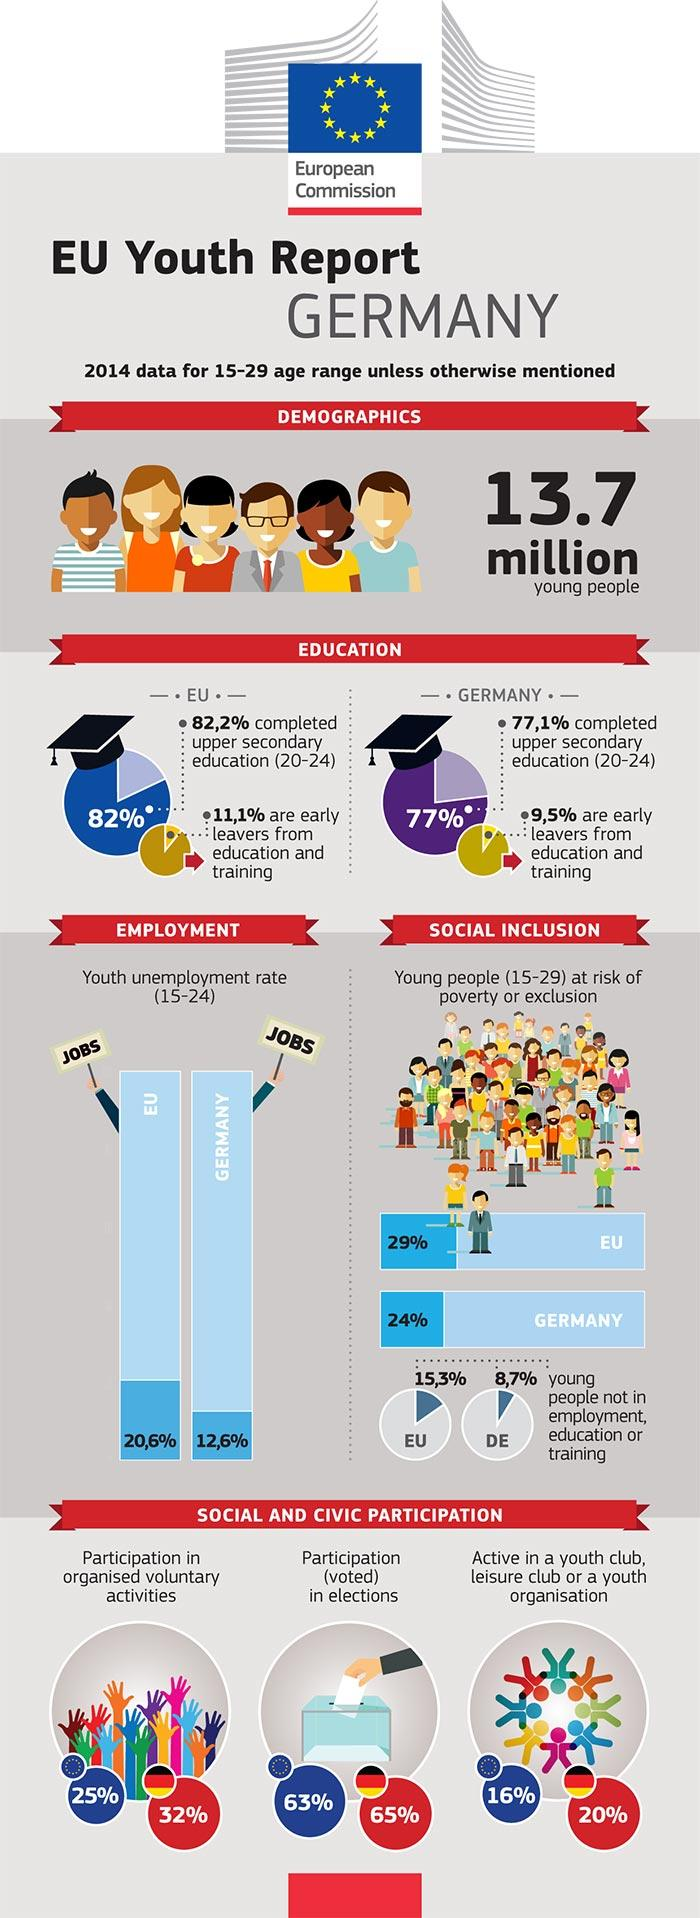Specify some key components in this picture. 63% of youth in the EU participate in elections. According to recent statistics, 65% of youth in Germany participate in elections. According to statistics, approximately 20% of the youth in Germany are actively involved in youth organizations. According to data, approximately 16% of the youth in the EU are actively involved in youth organizations. According to statistics, 32% of the youth in Germany participate in organized voluntary activities. 